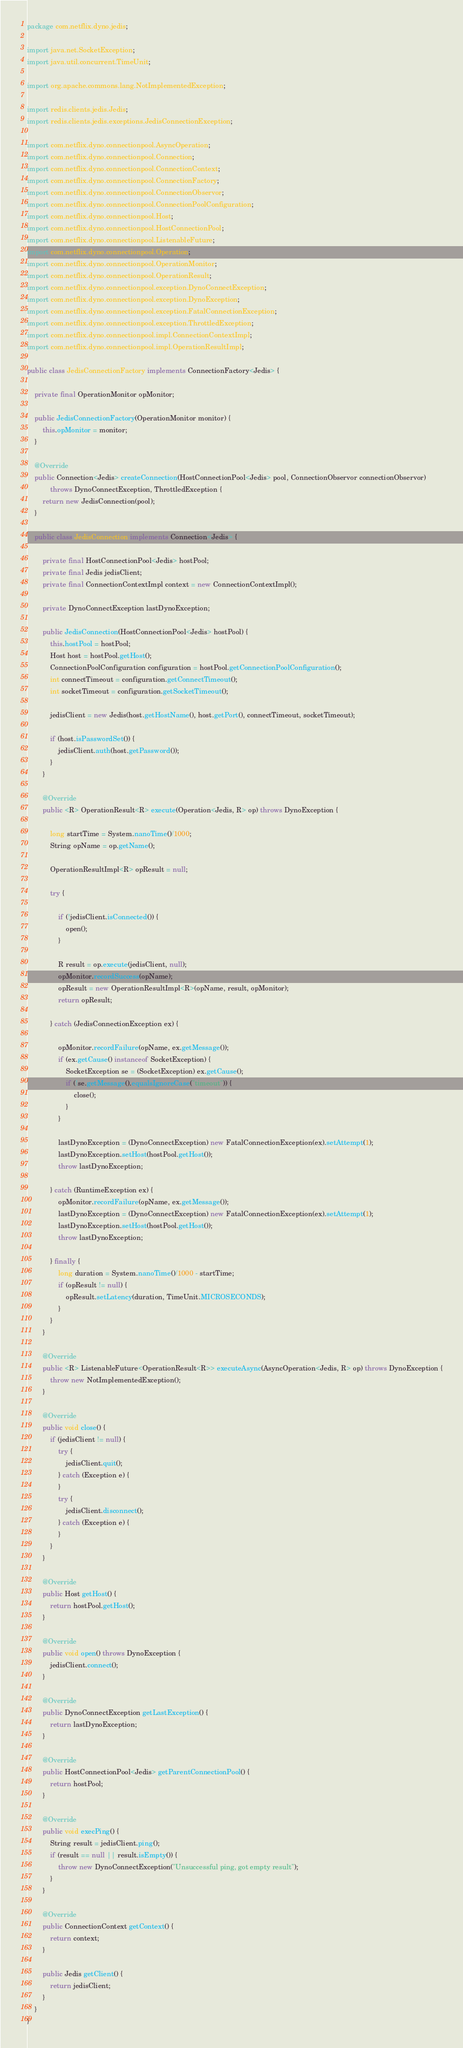<code> <loc_0><loc_0><loc_500><loc_500><_Java_>package com.netflix.dyno.jedis;

import java.net.SocketException;
import java.util.concurrent.TimeUnit;

import org.apache.commons.lang.NotImplementedException;

import redis.clients.jedis.Jedis;
import redis.clients.jedis.exceptions.JedisConnectionException;

import com.netflix.dyno.connectionpool.AsyncOperation;
import com.netflix.dyno.connectionpool.Connection;
import com.netflix.dyno.connectionpool.ConnectionContext;
import com.netflix.dyno.connectionpool.ConnectionFactory;
import com.netflix.dyno.connectionpool.ConnectionObservor;
import com.netflix.dyno.connectionpool.ConnectionPoolConfiguration;
import com.netflix.dyno.connectionpool.Host;
import com.netflix.dyno.connectionpool.HostConnectionPool;
import com.netflix.dyno.connectionpool.ListenableFuture;
import com.netflix.dyno.connectionpool.Operation;
import com.netflix.dyno.connectionpool.OperationMonitor;
import com.netflix.dyno.connectionpool.OperationResult;
import com.netflix.dyno.connectionpool.exception.DynoConnectException;
import com.netflix.dyno.connectionpool.exception.DynoException;
import com.netflix.dyno.connectionpool.exception.FatalConnectionException;
import com.netflix.dyno.connectionpool.exception.ThrottledException;
import com.netflix.dyno.connectionpool.impl.ConnectionContextImpl;
import com.netflix.dyno.connectionpool.impl.OperationResultImpl;

public class JedisConnectionFactory implements ConnectionFactory<Jedis> {

	private final OperationMonitor opMonitor; 
	
	public JedisConnectionFactory(OperationMonitor monitor) {
		this.opMonitor = monitor;
	}
	
	@Override
	public Connection<Jedis> createConnection(HostConnectionPool<Jedis> pool, ConnectionObservor connectionObservor) 
			throws DynoConnectException, ThrottledException {
		return new JedisConnection(pool);
	}

	public class JedisConnection implements Connection<Jedis> {

		private final HostConnectionPool<Jedis> hostPool;
		private final Jedis jedisClient; 
		private final ConnectionContextImpl context = new ConnectionContextImpl();
		
		private DynoConnectException lastDynoException;
		
		public JedisConnection(HostConnectionPool<Jedis> hostPool) {
			this.hostPool = hostPool;
			Host host = hostPool.getHost();
			ConnectionPoolConfiguration configuration = hostPool.getConnectionPoolConfiguration();
			int connectTimeout = configuration.getConnectTimeout();
			int socketTimeout = configuration.getSocketTimeout();

			jedisClient = new Jedis(host.getHostName(), host.getPort(), connectTimeout, socketTimeout);

			if (host.isPasswordSet()) {
				jedisClient.auth(host.getPassword());
			}
		}
		
		@Override
		public <R> OperationResult<R> execute(Operation<Jedis, R> op) throws DynoException {
			
			long startTime = System.nanoTime()/1000;
			String opName = op.getName();

			OperationResultImpl<R> opResult = null;
			
			try { 
				
				if (!jedisClient.isConnected()) {
					open();
				}
				
				R result = op.execute(jedisClient, null);
				opMonitor.recordSuccess(opName);
				opResult = new OperationResultImpl<R>(opName, result, opMonitor);
				return opResult;
				
			} catch (JedisConnectionException ex) {
				
				opMonitor.recordFailure(opName, ex.getMessage());
				if (ex.getCause() instanceof SocketException) {
					SocketException se = (SocketException) ex.getCause();
					if (!se.getMessage().equalsIgnoreCase("timeout")) {
						close();
					}
				}
				
				lastDynoException = (DynoConnectException) new FatalConnectionException(ex).setAttempt(1);
				lastDynoException.setHost(hostPool.getHost());
				throw lastDynoException;

			} catch (RuntimeException ex) {
				opMonitor.recordFailure(opName, ex.getMessage());
				lastDynoException = (DynoConnectException) new FatalConnectionException(ex).setAttempt(1);
				lastDynoException.setHost(hostPool.getHost());
				throw lastDynoException;
				
			} finally {
				long duration = System.nanoTime()/1000 - startTime;
				if (opResult != null) {
					opResult.setLatency(duration, TimeUnit.MICROSECONDS);
				}
			}
		}

		@Override
		public <R> ListenableFuture<OperationResult<R>> executeAsync(AsyncOperation<Jedis, R> op) throws DynoException {
			throw new NotImplementedException();
		}

		@Override
		public void close() {
			if (jedisClient != null) {
				try {
					jedisClient.quit();
				} catch (Exception e) {
				}
				try {
					jedisClient.disconnect();
				} catch (Exception e) {
				}
			}
		}

		@Override
		public Host getHost() {
			return hostPool.getHost();
		}

		@Override
		public void open() throws DynoException {
			jedisClient.connect();
		}

		@Override
		public DynoConnectException getLastException() {
			return lastDynoException;
		}

		@Override
		public HostConnectionPool<Jedis> getParentConnectionPool() {
			return hostPool;
		}

		@Override
		public void execPing() {
			String result = jedisClient.ping();
			if (result == null || result.isEmpty()) {
				throw new DynoConnectException("Unsuccessful ping, got empty result");
			}
		}

		@Override
		public ConnectionContext getContext() {
			return context;
		}
		
		public Jedis getClient() {
			return jedisClient;
		}
	}
}
</code> 